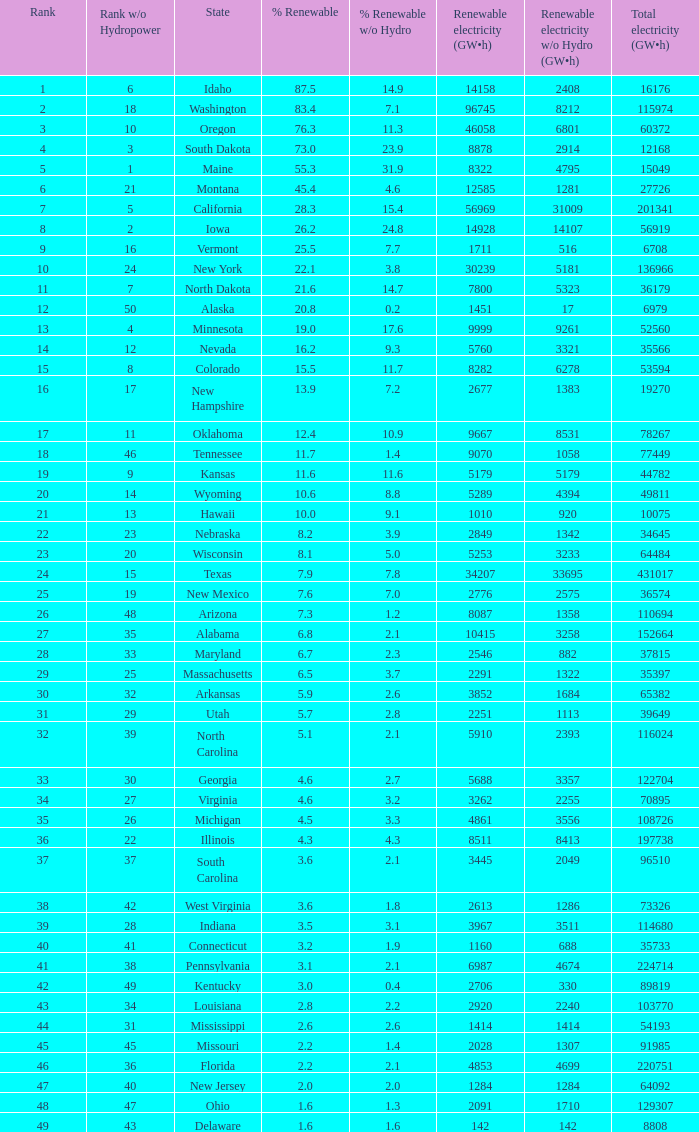Which states possess renewable electricity equivalent to 9667 (gw×h)? Oklahoma. 